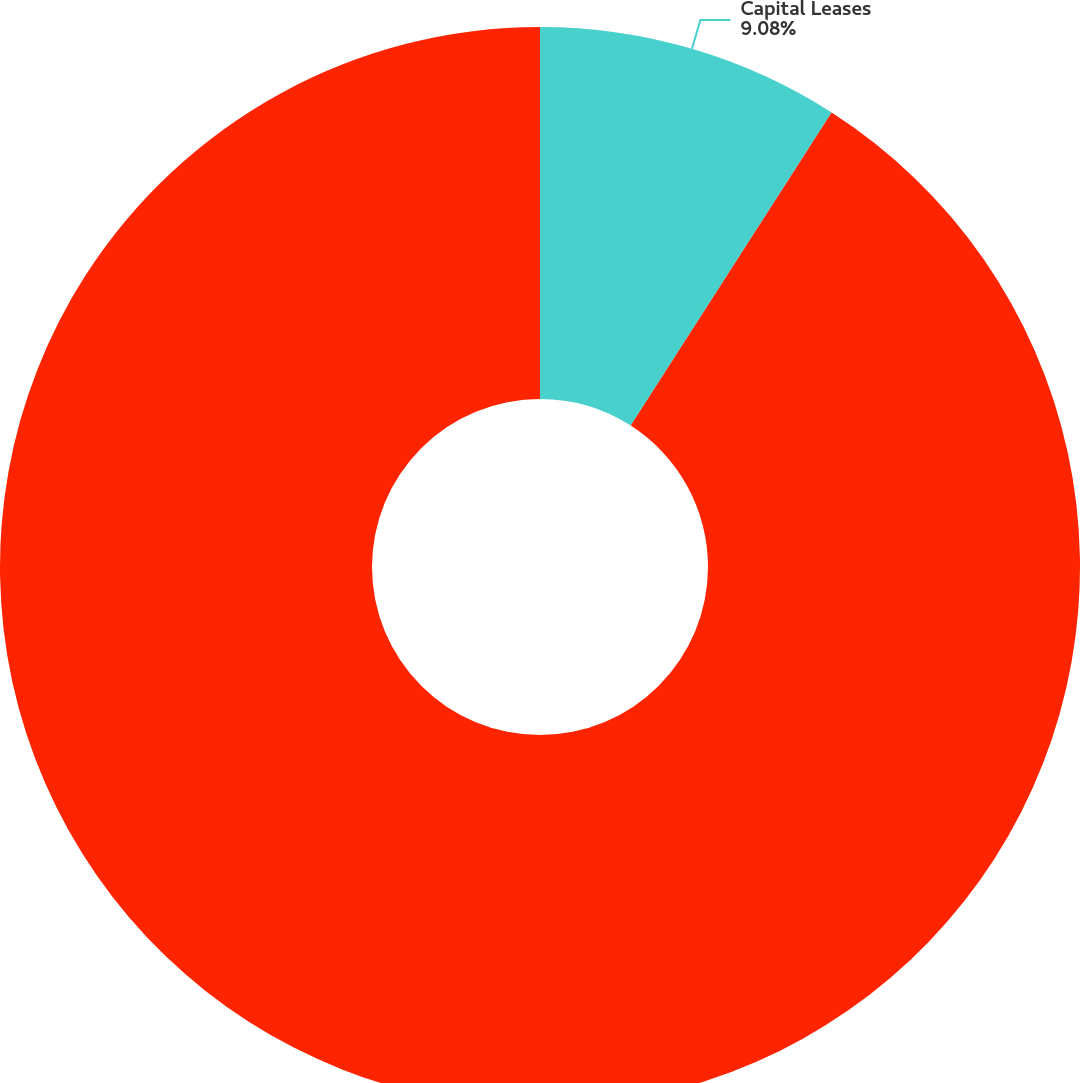Convert chart to OTSL. <chart><loc_0><loc_0><loc_500><loc_500><pie_chart><fcel>Capital Leases<fcel>Operating Leases<nl><fcel>9.08%<fcel>90.92%<nl></chart> 